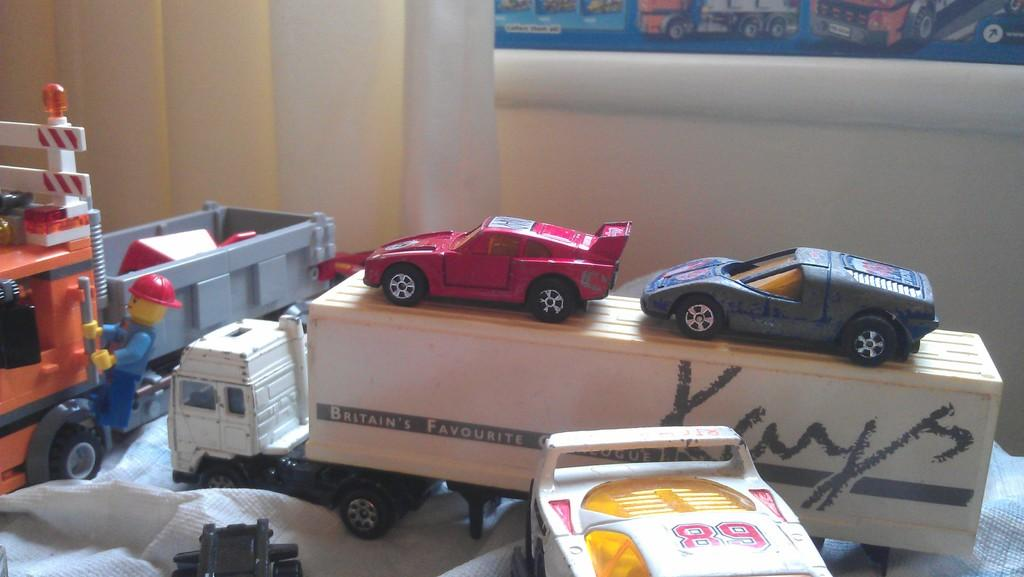What type of objects are in the image? There is a group of toy vehicles in the image. Where are the toy vehicles located? The toy vehicles are placed on a table. What can be seen in the background of the image? There is a photo and a curtain in the background of the image. How much toothpaste is on the rock in the image? There is no toothpaste or rock present in the image. 